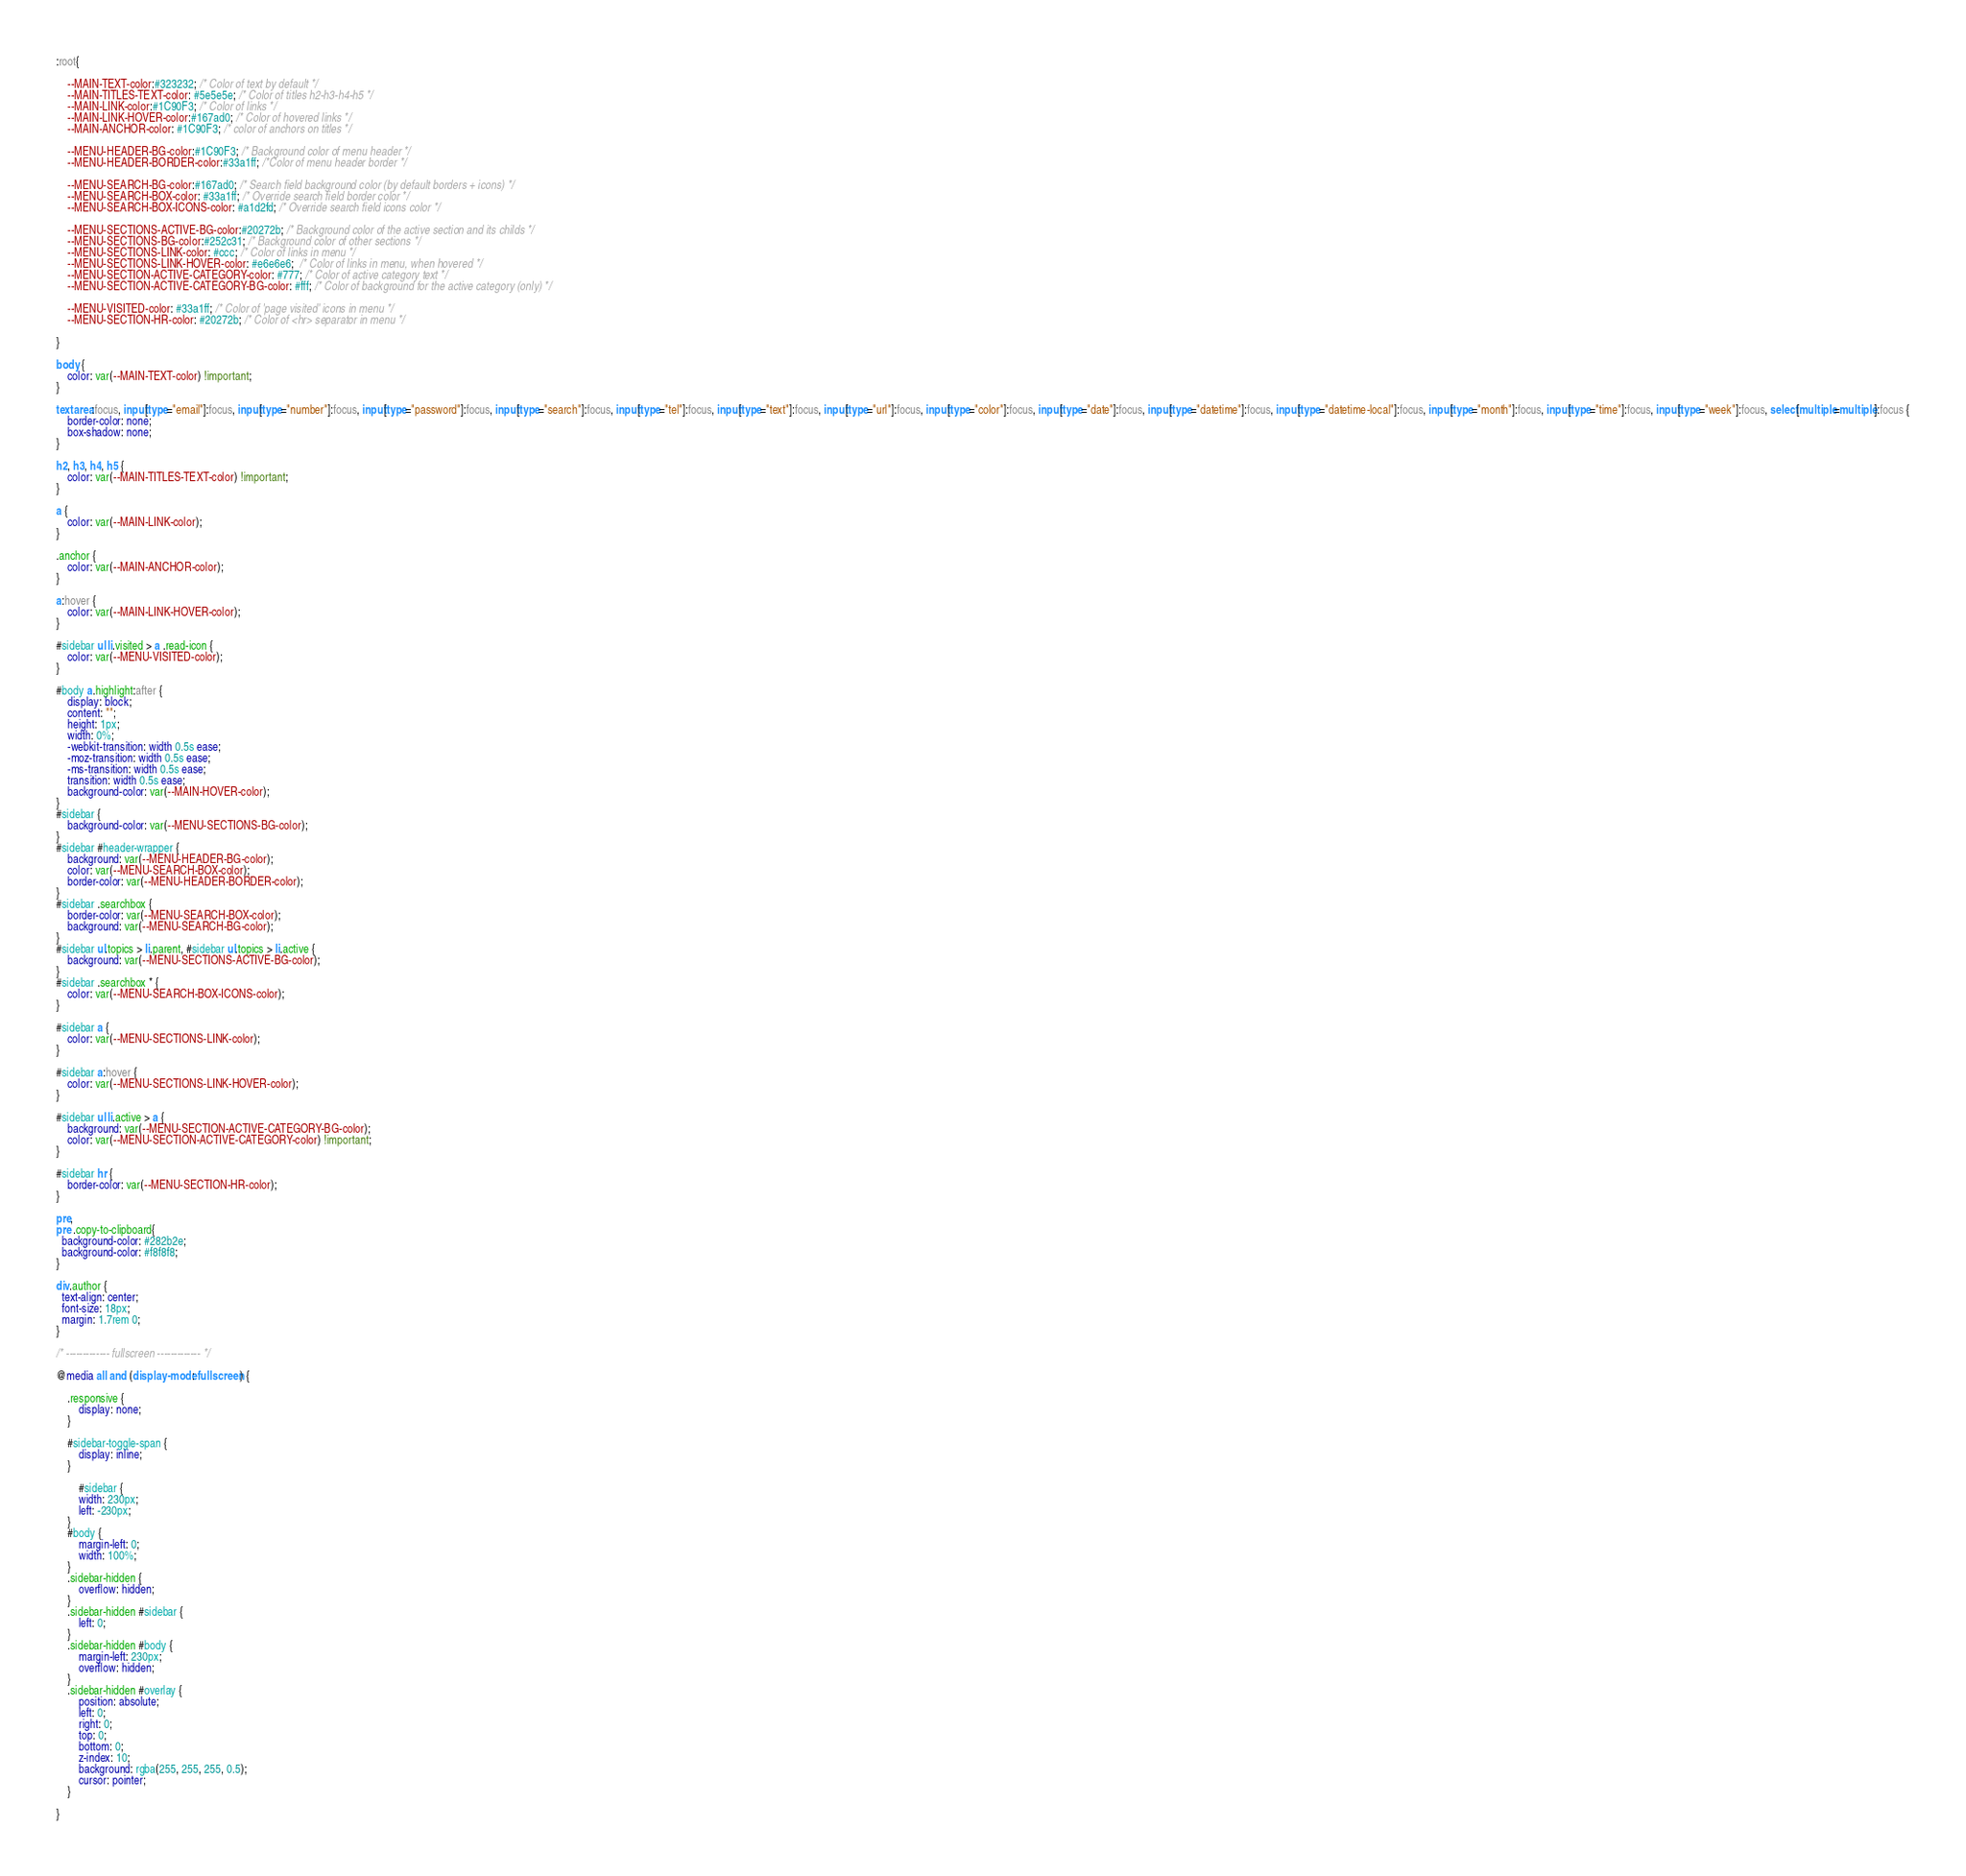Convert code to text. <code><loc_0><loc_0><loc_500><loc_500><_CSS_>
:root{
    
    --MAIN-TEXT-color:#323232; /* Color of text by default */
    --MAIN-TITLES-TEXT-color: #5e5e5e; /* Color of titles h2-h3-h4-h5 */
    --MAIN-LINK-color:#1C90F3; /* Color of links */
    --MAIN-LINK-HOVER-color:#167ad0; /* Color of hovered links */
    --MAIN-ANCHOR-color: #1C90F3; /* color of anchors on titles */

    --MENU-HEADER-BG-color:#1C90F3; /* Background color of menu header */
    --MENU-HEADER-BORDER-color:#33a1ff; /*Color of menu header border */ 

    --MENU-SEARCH-BG-color:#167ad0; /* Search field background color (by default borders + icons) */
    --MENU-SEARCH-BOX-color: #33a1ff; /* Override search field border color */
    --MENU-SEARCH-BOX-ICONS-color: #a1d2fd; /* Override search field icons color */

    --MENU-SECTIONS-ACTIVE-BG-color:#20272b; /* Background color of the active section and its childs */
    --MENU-SECTIONS-BG-color:#252c31; /* Background color of other sections */
    --MENU-SECTIONS-LINK-color: #ccc; /* Color of links in menu */
    --MENU-SECTIONS-LINK-HOVER-color: #e6e6e6;  /* Color of links in menu, when hovered */
    --MENU-SECTION-ACTIVE-CATEGORY-color: #777; /* Color of active category text */
    --MENU-SECTION-ACTIVE-CATEGORY-BG-color: #fff; /* Color of background for the active category (only) */

    --MENU-VISITED-color: #33a1ff; /* Color of 'page visited' icons in menu */
    --MENU-SECTION-HR-color: #20272b; /* Color of <hr> separator in menu */
    
}

body {
    color: var(--MAIN-TEXT-color) !important;
}

textarea:focus, input[type="email"]:focus, input[type="number"]:focus, input[type="password"]:focus, input[type="search"]:focus, input[type="tel"]:focus, input[type="text"]:focus, input[type="url"]:focus, input[type="color"]:focus, input[type="date"]:focus, input[type="datetime"]:focus, input[type="datetime-local"]:focus, input[type="month"]:focus, input[type="time"]:focus, input[type="week"]:focus, select[multiple=multiple]:focus {
    border-color: none;
    box-shadow: none;
}

h2, h3, h4, h5 {
    color: var(--MAIN-TITLES-TEXT-color) !important;
}

a {
    color: var(--MAIN-LINK-color);
}

.anchor {
    color: var(--MAIN-ANCHOR-color);
}

a:hover {
    color: var(--MAIN-LINK-HOVER-color);
}

#sidebar ul li.visited > a .read-icon {
	color: var(--MENU-VISITED-color);
}

#body a.highlight:after {
    display: block;
    content: "";
    height: 1px;
    width: 0%;
    -webkit-transition: width 0.5s ease;
    -moz-transition: width 0.5s ease;
    -ms-transition: width 0.5s ease;
    transition: width 0.5s ease;
    background-color: var(--MAIN-HOVER-color);
}
#sidebar {
	background-color: var(--MENU-SECTIONS-BG-color);
}
#sidebar #header-wrapper {
    background: var(--MENU-HEADER-BG-color);
    color: var(--MENU-SEARCH-BOX-color);
    border-color: var(--MENU-HEADER-BORDER-color);
}
#sidebar .searchbox {
	border-color: var(--MENU-SEARCH-BOX-color);
    background: var(--MENU-SEARCH-BG-color);
}
#sidebar ul.topics > li.parent, #sidebar ul.topics > li.active {
    background: var(--MENU-SECTIONS-ACTIVE-BG-color);
}
#sidebar .searchbox * {
    color: var(--MENU-SEARCH-BOX-ICONS-color);
}

#sidebar a {
    color: var(--MENU-SECTIONS-LINK-color);
}

#sidebar a:hover {
    color: var(--MENU-SECTIONS-LINK-HOVER-color);
}

#sidebar ul li.active > a {
    background: var(--MENU-SECTION-ACTIVE-CATEGORY-BG-color);
    color: var(--MENU-SECTION-ACTIVE-CATEGORY-color) !important;
}

#sidebar hr {
    border-color: var(--MENU-SECTION-HR-color);
}

pre,
pre .copy-to-clipboard{
  background-color: #282b2e;
  background-color: #f8f8f8;
}

div.author {
  text-align: center;
  font-size: 18px;
  margin: 1.7rem 0;
}

/* ------------- fullscreen ------------- */

@media all and (display-mode: fullscreen) {
  
    .responsive {
        display: none;
    }
    
    #sidebar-toggle-span {
        display: inline;
    }
    
        #sidebar {
        width: 230px;
        left: -230px;
    }
    #body {
        margin-left: 0;
        width: 100%;
    }
    .sidebar-hidden {
        overflow: hidden;
    }
    .sidebar-hidden #sidebar {
        left: 0;
    }
    .sidebar-hidden #body {
        margin-left: 230px;
        overflow: hidden;
    }
    .sidebar-hidden #overlay {
        position: absolute;
        left: 0;
        right: 0;
        top: 0;
        bottom: 0;
        z-index: 10;
        background: rgba(255, 255, 255, 0.5);
        cursor: pointer;
    }

}


</code> 